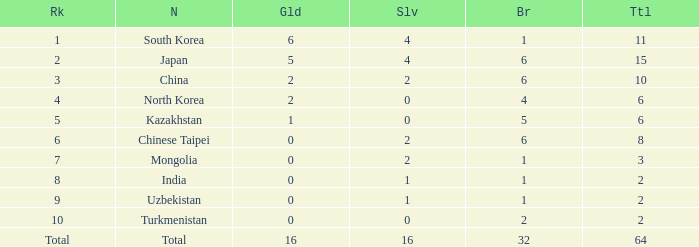What's the biggest Bronze that has less than 0 Silvers? None. 